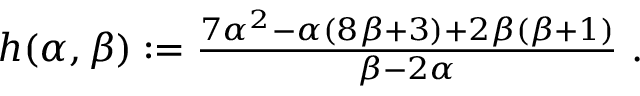<formula> <loc_0><loc_0><loc_500><loc_500>\begin{array} { r } { h ( \alpha , \beta ) \colon = \frac { 7 \alpha ^ { 2 } - \alpha ( 8 \beta + 3 ) + 2 \beta ( \beta + 1 ) } { \beta - 2 \alpha } \ . } \end{array}</formula> 